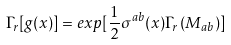<formula> <loc_0><loc_0><loc_500><loc_500>\Gamma _ { r } [ g ( x ) ] = e x p [ { \frac { 1 } { 2 } } \sigma ^ { a b } ( x ) \Gamma _ { r } \left ( M _ { a b } \right ) ]</formula> 